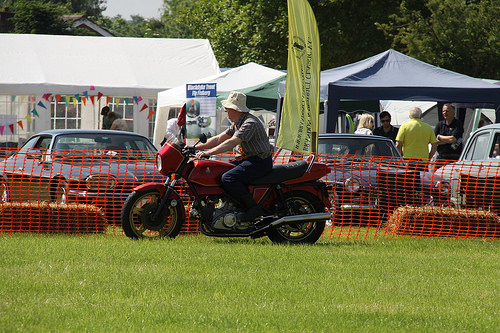<image>
Can you confirm if the man is behind the bike? No. The man is not behind the bike. From this viewpoint, the man appears to be positioned elsewhere in the scene. 